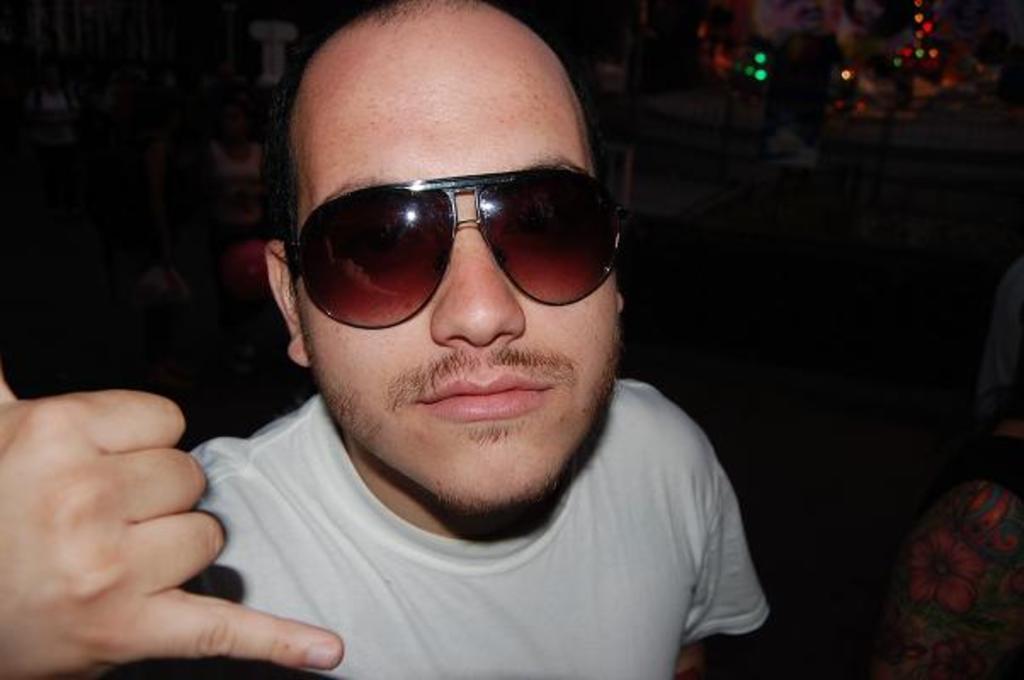Could you give a brief overview of what you see in this image? In this image the background is dark. There are a few lights. In the middle of the image there is a man. 